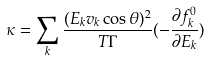<formula> <loc_0><loc_0><loc_500><loc_500>\kappa = \sum _ { k } \frac { ( E _ { k } v _ { k } \cos \theta ) ^ { 2 } } { T \Gamma } ( - \frac { \partial f _ { k } ^ { 0 } } { \partial E _ { k } } )</formula> 